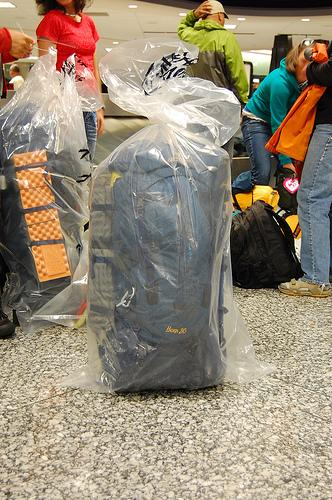List three things that the people are holding or wearing in the image. An orange jacket, a red top, and a baseball cap. How many backpacks are visible in the image? There are three backpacks visible in the image. Describe the state of the luggage in the image. Some luggage is wrapped in plastic, one is inside a large plastic bag, and a blue one is placed next to a person. What is the flooring made of in the image? The floor has a granite pattern with tiles. Give a brief description of an interesting object interaction in the image. A person is holding an orange jacket while waiting in line with their luggage. Explain the overall mood of the image. The image shows a busy atmosphere with people waiting in line with their luggage and dealing with their belongings. What are the people doing in the image? People are waiting in line with luggage, holding jackets, picking up luggage, and wrapping their belongings in plastic. Count the number of people wearing jackets or sweatshirts in the image. There are five people wearing jackets or sweatshirts. What type of luggage is in plastic in the image? One blue luggage and a dufflebag are wrapped in plastic. Identify the color of the jacket worn by one of the travelers. The traveler is wearing a green jacket. Describe the features of the black backpack sitting on the floor within the left-bottom quadrant of the image. The black backpack has a compact design, sitting sturdily on the granite-patterned floor with its robust straps and functional zippers. Identify any type of footwear seen in the lower-right quadrant of the image. Socks and sandals Is there a person walking with a dog in this image? There is no mention of a person walking with a dog in the given information. This instruction will confuse users as they try to find an object with a non-existent attribute. Where is the man carrying a blue umbrella? There is no mention of a man carrying a blue umbrella. This instruction will confuse users as the attribute does not exist in the objects provided. Does the child wearing sunglasses appear at any part of the image? There are no objects in the given information that refers to a child wearing sunglasses. This instruction will cause users to search for a non-existent object. Can you spot the woman wearing a yellow dress in the image? There is no mention of a woman wearing a yellow dress. This instruction will mislead the users as there is no object with the specified attribute. Where is the large red suitcase in the line of people waiting? There are no objects that contain information about a large red suitcase. This instruction will mislead users as they attempt to find an object with the specified attribute that does not exist in the image. Write an imaginative sentence about the scene in the image, focusing on the relationship between the people waiting in line and their luggage. Packed in plastic and united in anticipation, the weary travelers join their luggage in line for an adventure of a lifetime. Create a metaphorical description of the floor in the bottom-left corner of the image. The floor, a patchwork quilt of granite, creates an elaborate mosaic for the travelers to walk upon. Which object is wrapped in a plastic bag located at the center of the image? A hiking pack Can you find the cat sleeping next to the luggage? There is no mention of a cat, sleeping or otherwise, in the given objects. This instruction will mislead the users because the specified attribute is not present in the objects. Create a poem that incorporates the colors of the various jackets and tops worn by the people in the image. In the sea of the waiting crowd, Read the text on any clothing or signage in the image. No text visible What color is the jacket held by the traveler at the top-right corner of the image? Orange Describe the type of shirt or top that the person at the top-middle of the image is wearing, as well as their hair accessory or hairstyle. Red top, sunglasses on top of the head 